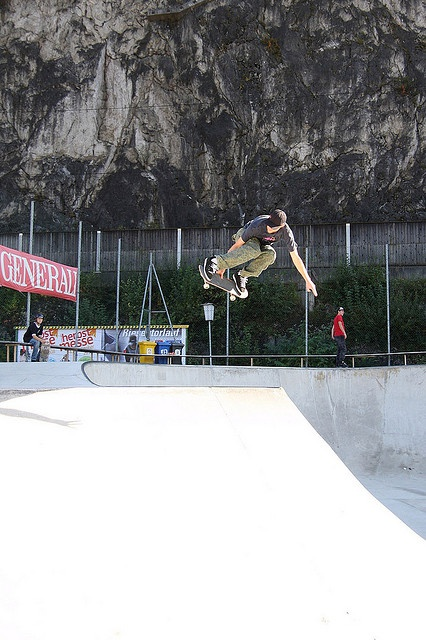Describe the objects in this image and their specific colors. I can see people in black, gray, darkgray, and tan tones, people in black, brown, and gray tones, skateboard in black, gray, white, and darkgray tones, people in black, gray, and navy tones, and people in black and gray tones in this image. 